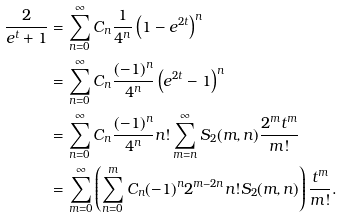<formula> <loc_0><loc_0><loc_500><loc_500>\frac { 2 } { e ^ { t } + 1 } & = \sum _ { n = 0 } ^ { \infty } C _ { n } \frac { 1 } { 4 ^ { n } } \left ( 1 - e ^ { 2 t } \right ) ^ { n } \\ & = \sum _ { n = 0 } ^ { \infty } C _ { n } \frac { ( - 1 ) ^ { n } } { 4 ^ { n } } \left ( e ^ { 2 t } - 1 \right ) ^ { n } \\ & = \sum _ { n = 0 } ^ { \infty } C _ { n } \frac { ( - 1 ) ^ { n } } { 4 ^ { n } } n ! \sum _ { m = n } ^ { \infty } S _ { 2 } ( m , n ) \frac { 2 ^ { m } t ^ { m } } { m ! } \\ & = \sum _ { m = 0 } ^ { \infty } \left ( \sum _ { n = 0 } ^ { m } C _ { n } ( - 1 ) ^ { n } 2 ^ { m - 2 n } n ! S _ { 2 } ( m , n ) \right ) \frac { t ^ { m } } { m ! } .</formula> 